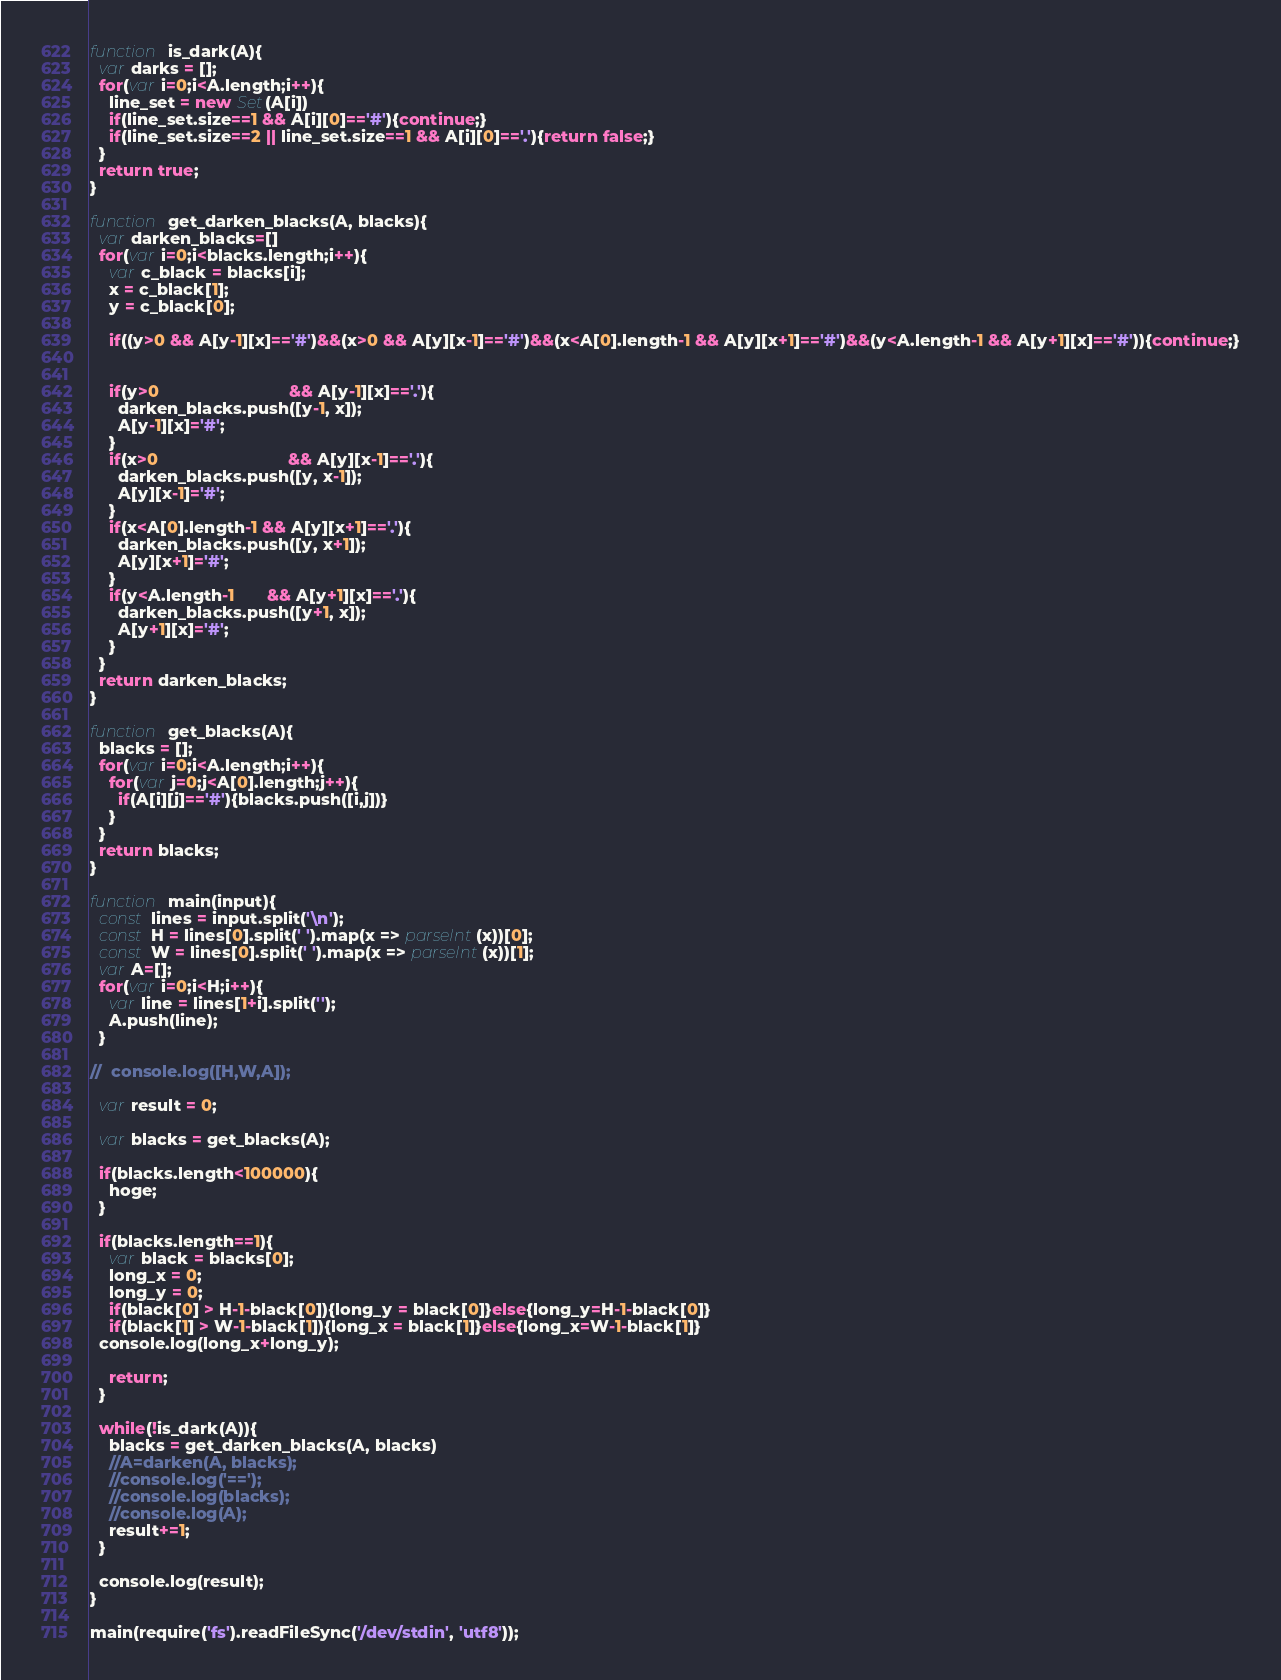<code> <loc_0><loc_0><loc_500><loc_500><_JavaScript_>function is_dark(A){
  var darks = [];
  for(var i=0;i<A.length;i++){
    line_set = new Set(A[i])
    if(line_set.size==1 && A[i][0]=='#'){continue;}
    if(line_set.size==2 || line_set.size==1 && A[i][0]=='.'){return false;}
  }
  return true;
}

function get_darken_blacks(A, blacks){
  var darken_blacks=[]
  for(var i=0;i<blacks.length;i++){
    var c_black = blacks[i];
    x = c_black[1];
    y = c_black[0];

    if((y>0 && A[y-1][x]=='#')&&(x>0 && A[y][x-1]=='#')&&(x<A[0].length-1 && A[y][x+1]=='#')&&(y<A.length-1 && A[y+1][x]=='#')){continue;}


    if(y>0                            && A[y-1][x]=='.'){
      darken_blacks.push([y-1, x]);
      A[y-1][x]='#';
    }
    if(x>0                            && A[y][x-1]=='.'){
      darken_blacks.push([y, x-1]);
      A[y][x-1]='#';
    }
    if(x<A[0].length-1 && A[y][x+1]=='.'){
      darken_blacks.push([y, x+1]);
      A[y][x+1]='#';
    }
    if(y<A.length-1       && A[y+1][x]=='.'){
      darken_blacks.push([y+1, x]);
      A[y+1][x]='#';
    }
  }
  return darken_blacks;
}

function get_blacks(A){
  blacks = [];
  for(var i=0;i<A.length;i++){
    for(var j=0;j<A[0].length;j++){
      if(A[i][j]=='#'){blacks.push([i,j])}
    }
  }
  return blacks;
}

function main(input){
  const lines = input.split('\n');
  const H = lines[0].split(' ').map(x => parseInt(x))[0];
  const W = lines[0].split(' ').map(x => parseInt(x))[1];
  var A=[];
  for(var i=0;i<H;i++){
    var line = lines[1+i].split('');
    A.push(line);
  }

//  console.log([H,W,A]);

  var result = 0;

  var blacks = get_blacks(A);

  if(blacks.length<100000){
    hoge;
  }

  if(blacks.length==1){
    var black = blacks[0];
    long_x = 0;
    long_y = 0;
    if(black[0] > H-1-black[0]){long_y = black[0]}else{long_y=H-1-black[0]}
    if(black[1] > W-1-black[1]){long_x = black[1]}else{long_x=W-1-black[1]}
  console.log(long_x+long_y);

    return;
  }

  while(!is_dark(A)){
    blacks = get_darken_blacks(A, blacks)
    //A=darken(A, blacks);
    //console.log('==');
    //console.log(blacks);
    //console.log(A);
    result+=1;
  }

  console.log(result);
}

main(require('fs').readFileSync('/dev/stdin', 'utf8'));
</code> 